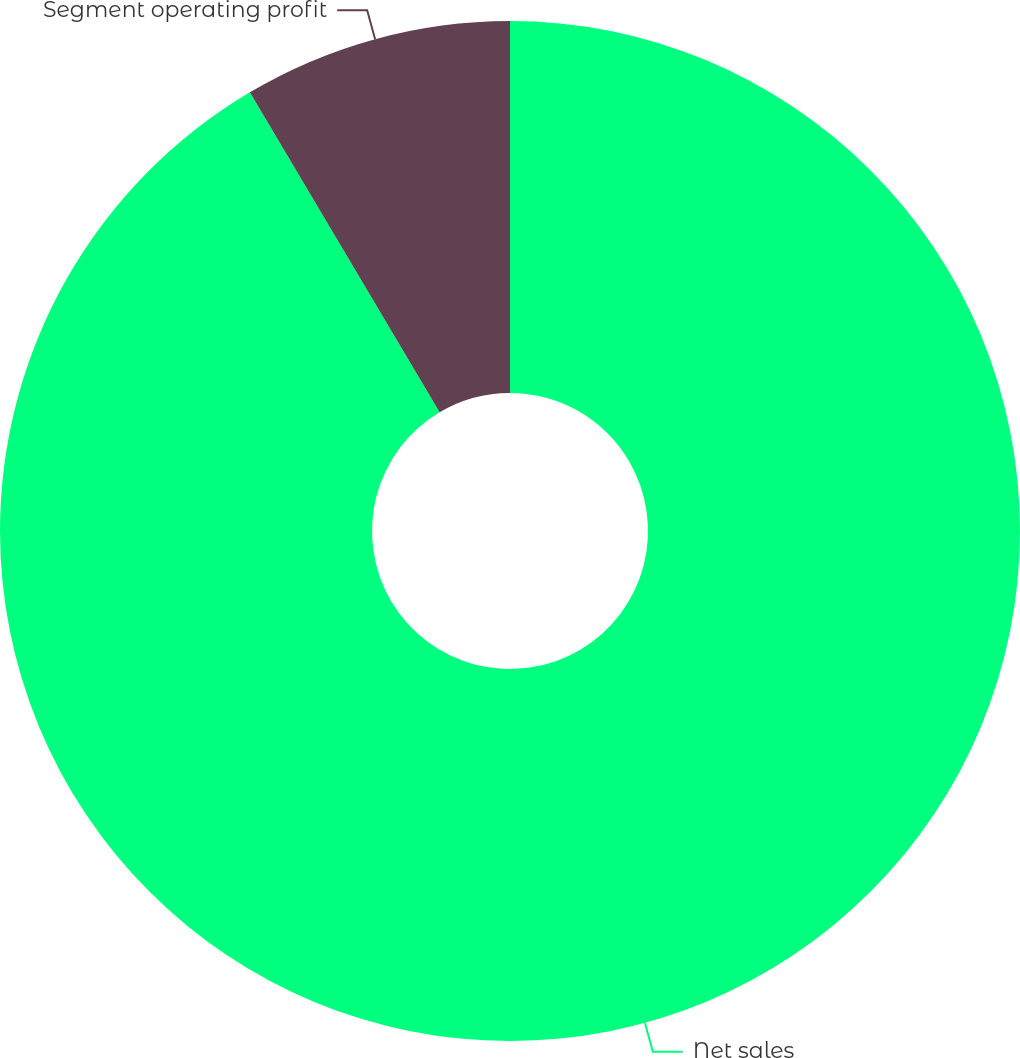Convert chart to OTSL. <chart><loc_0><loc_0><loc_500><loc_500><pie_chart><fcel>Net sales<fcel>Segment operating profit<nl><fcel>91.48%<fcel>8.52%<nl></chart> 